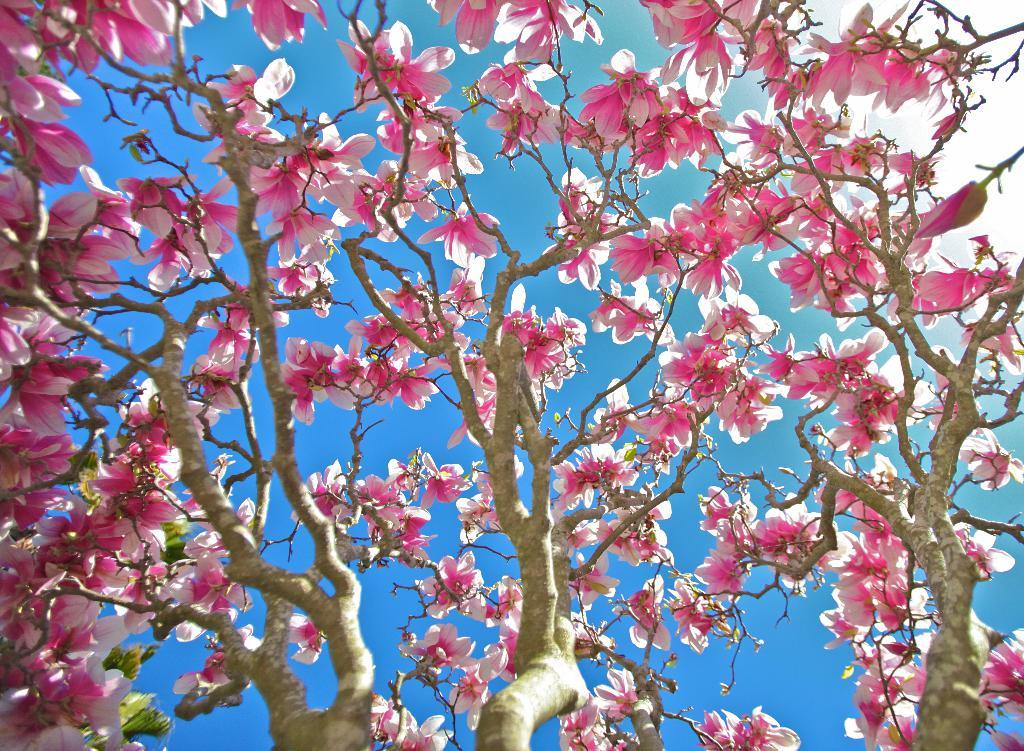What type of plants can be seen in the foreground of the image? There are flower plants in the foreground of the image. What color are the flower plants? The flower plants are pink in color. What can be seen in the background of the image? The sky is visible in the background of the image. What type of bulb is being used by the manager in the image? There is no manager or bulb present in the image; it features flower plants and the sky. Can you see the sea in the background of the image? No, the sea is not visible in the background of the image; it features the sky. 